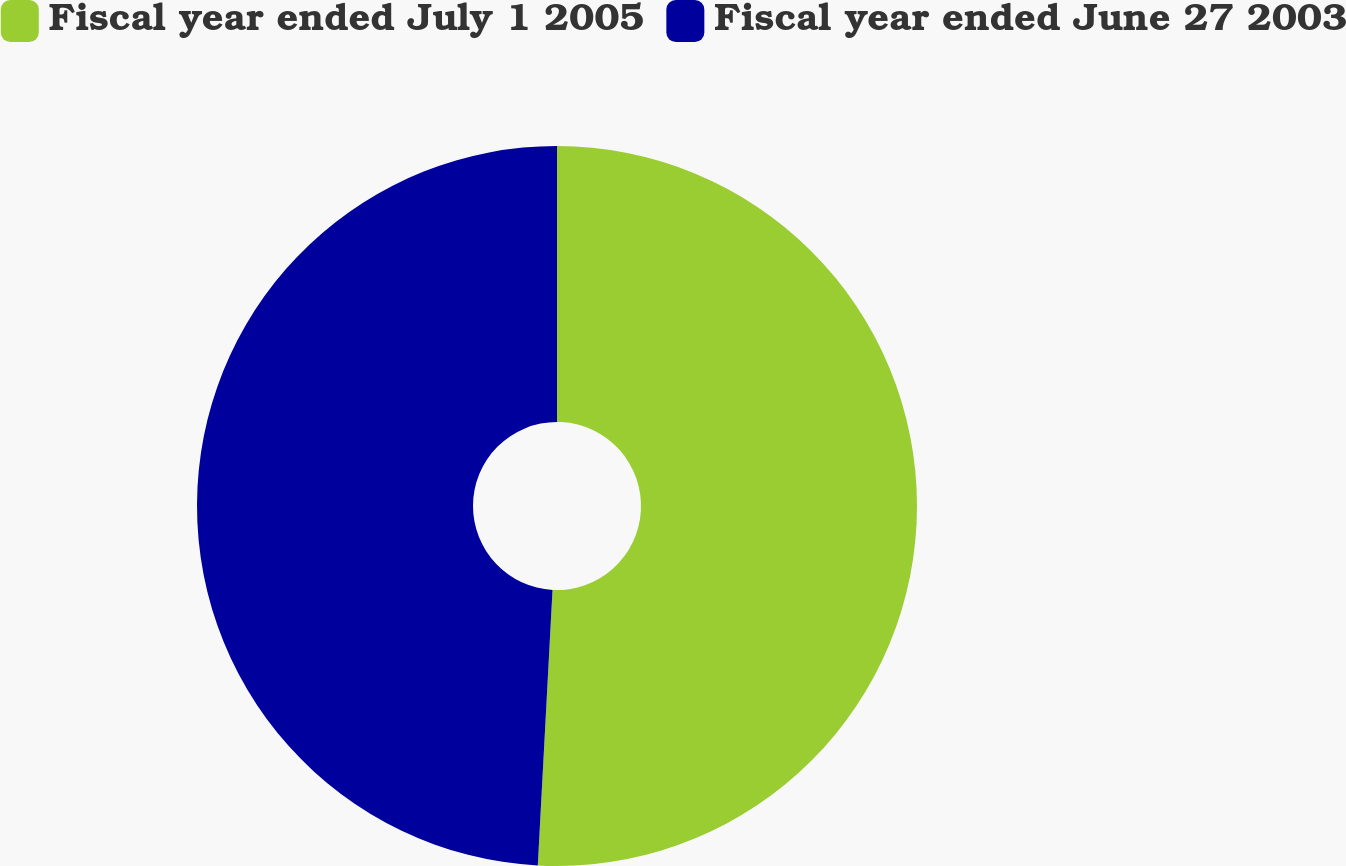Convert chart. <chart><loc_0><loc_0><loc_500><loc_500><pie_chart><fcel>Fiscal year ended July 1 2005<fcel>Fiscal year ended June 27 2003<nl><fcel>50.85%<fcel>49.15%<nl></chart> 